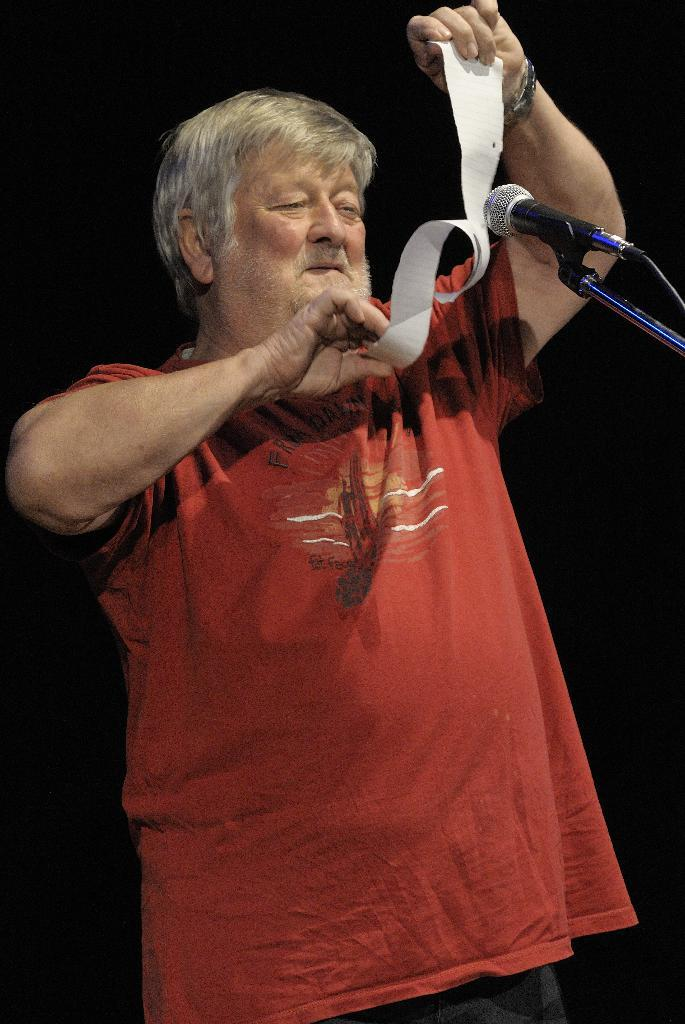Who is present in the image? There is a man in the image. What is the man doing in the image? The man is standing in the image. What is the man holding in his hands? The man is holding a paper in his hands. What can be seen on the right side of the image? There is a microphone on a stand on the right side of the image. How would you describe the background of the image? The background of the image is dark. What type of low is the man sitting on in the image? There is no low present in the image; the man is standing. Can you see a stamp on the paper the man is holding? There is no stamp visible on the paper the man is holding in the image. 